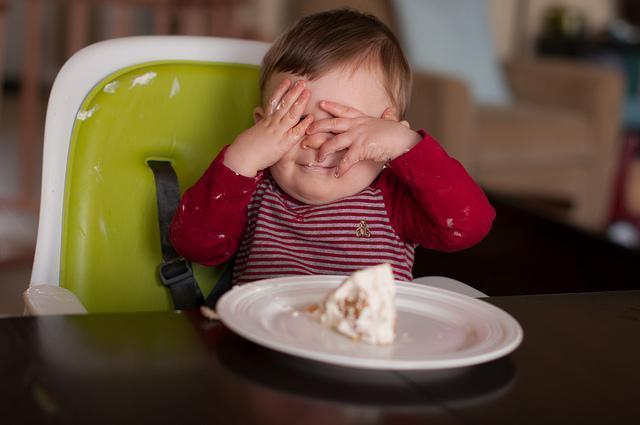How many giraffes are there?
Give a very brief answer. 0. 